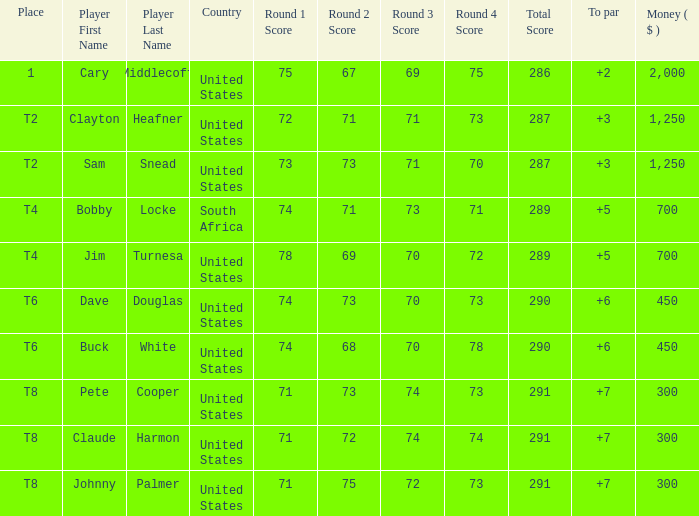What is Claude Harmon's Place? T8. 